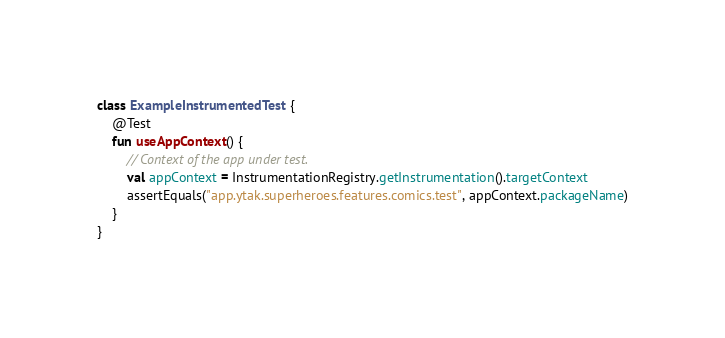Convert code to text. <code><loc_0><loc_0><loc_500><loc_500><_Kotlin_>class ExampleInstrumentedTest {
    @Test
    fun useAppContext() {
        // Context of the app under test.
        val appContext = InstrumentationRegistry.getInstrumentation().targetContext
        assertEquals("app.ytak.superheroes.features.comics.test", appContext.packageName)
    }
}
</code> 